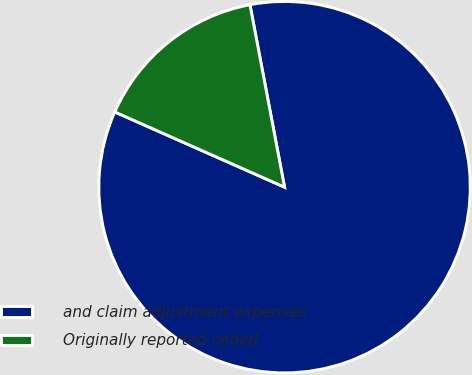Convert chart. <chart><loc_0><loc_0><loc_500><loc_500><pie_chart><fcel>and claim adjustment expenses<fcel>Originally reported ceded<nl><fcel>84.62%<fcel>15.38%<nl></chart> 